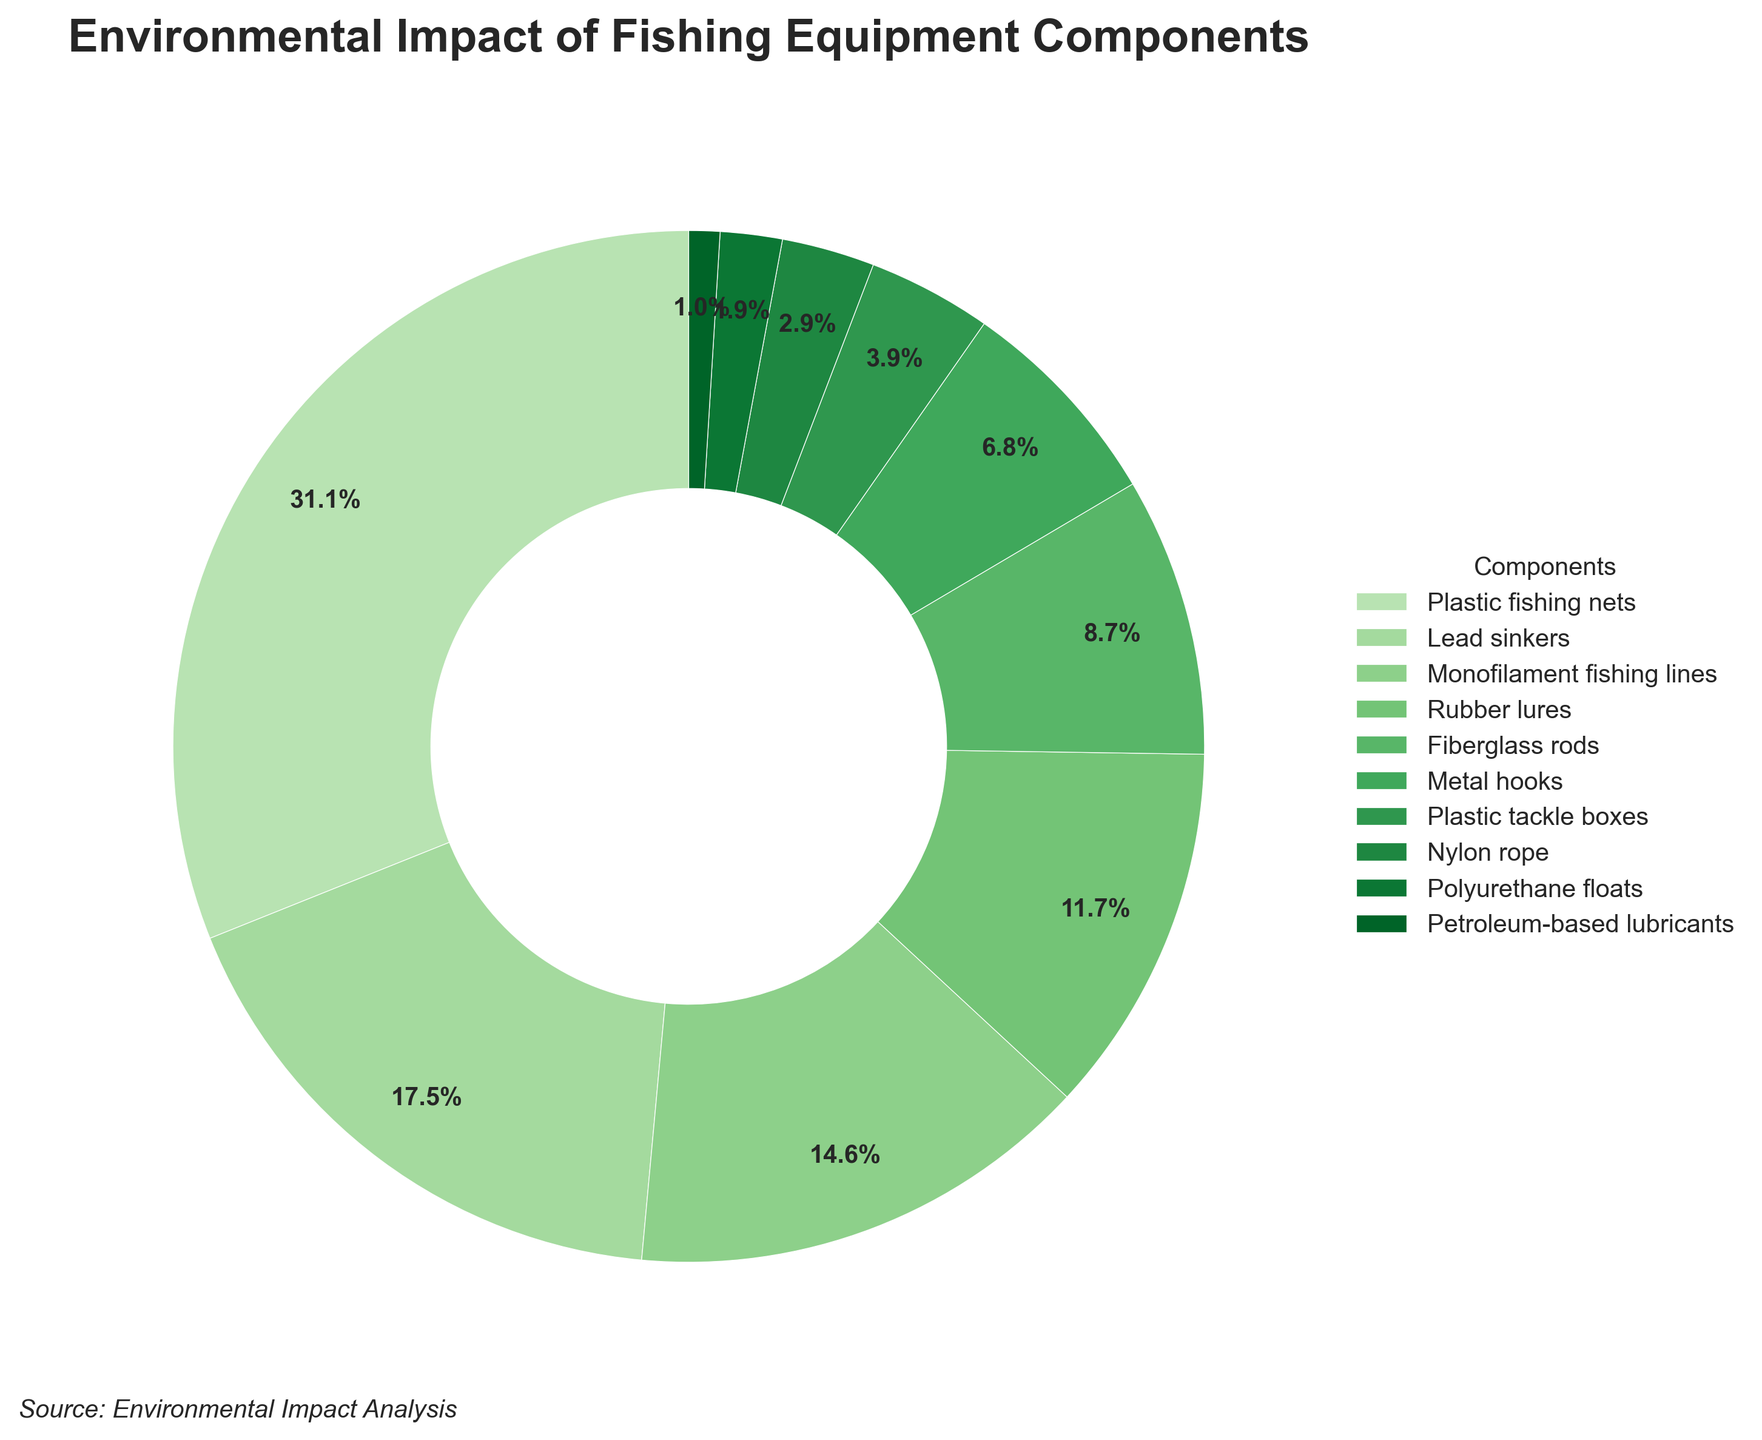What component has the highest environmental impact? The component with the largest section in the pie chart is "Plastic fishing nets," indicating it has the highest environmental impact.
Answer: Plastic fishing nets Which component has the lowest percentage of environmental impact? The smallest section on the pie chart represents "Petroleum-based lubricants," which has the lowest environmental impact percentage.
Answer: Petroleum-based lubricants What is the combined environmental impact percentage of Plastic fishing nets and Monofilament fishing lines? The percentage of Plastic fishing nets is 32% and Monofilament fishing lines is 15%. Adding them together gives 32 + 15 = 47%.
Answer: 47% Are Metal hooks responsible for a greater environmental impact than Plastic tackle boxes? Metal hooks have a percentage of 7%, while Plastic tackle boxes have 4%. Since 7% is greater than 4%, Metal hooks have a greater environmental impact.
Answer: Yes What is the environmental impact difference between Lead sinkers and Rubber lures? Lead sinkers have a percentage of 18%, while Rubber lures have 12%. The difference is 18 - 12 = 6%.
Answer: 6% Which components contribute to an environmental impact of less than 5% each? Components with less than 5% environmental impact are Plastic tackle boxes (4%), Nylon rope (3%), Polyurethane floats (2%), and Petroleum-based lubricants (1%).
Answer: Plastic tackle boxes, Nylon rope, Polyurethane floats, Petroleum-based lubricants Do Fiberglass rods and Metal hooks combined have an environmental impact higher than that of Rubber lures? Fiberglass rods have a 9% impact and Metal hooks have 7%. Combined, they total 9 + 7 = 16%, which is greater than the 12% impact of Rubber lures.
Answer: Yes Which component is represented by the lightest green shade in the pie chart? The lightest green shade in the pie chart represents "Plastic fishing nets," which has the highest environmental impact percentage.
Answer: Plastic fishing nets What is the average environmental impact percentage of Lead sinkers, Metal hooks, and Fiberglass rods? The percentages are Lead sinkers (18%), Metal hooks (7%), and Fiberglass rods (9%). The average is calculated as (18 + 7 + 9) / 3 = 34 / 3 ≈ 11.33%.
Answer: 11.33% What is the combined percentage for all plastics-related components? Plastics-related components are Plastic fishing nets (32%), Monofilament fishing lines (15%), Plastic tackle boxes (4%), and Polyurethane floats (2%). Adding them together gives 32 + 15 + 4 + 2 = 53%.
Answer: 53% 